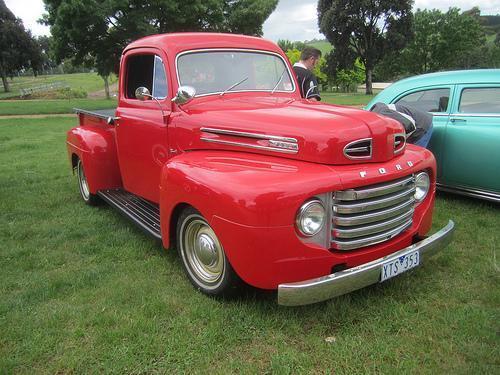How many cars are there?
Give a very brief answer. 2. How many people are in this picture?
Give a very brief answer. 1. 